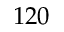Convert formula to latex. <formula><loc_0><loc_0><loc_500><loc_500>1 2 0</formula> 